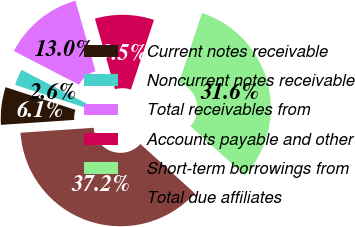Convert chart to OTSL. <chart><loc_0><loc_0><loc_500><loc_500><pie_chart><fcel>Current notes receivable<fcel>Noncurrent notes receivable<fcel>Total receivables from<fcel>Accounts payable and other<fcel>Short-term borrowings from<fcel>Total due affiliates<nl><fcel>6.06%<fcel>2.6%<fcel>12.98%<fcel>9.52%<fcel>31.62%<fcel>37.2%<nl></chart> 